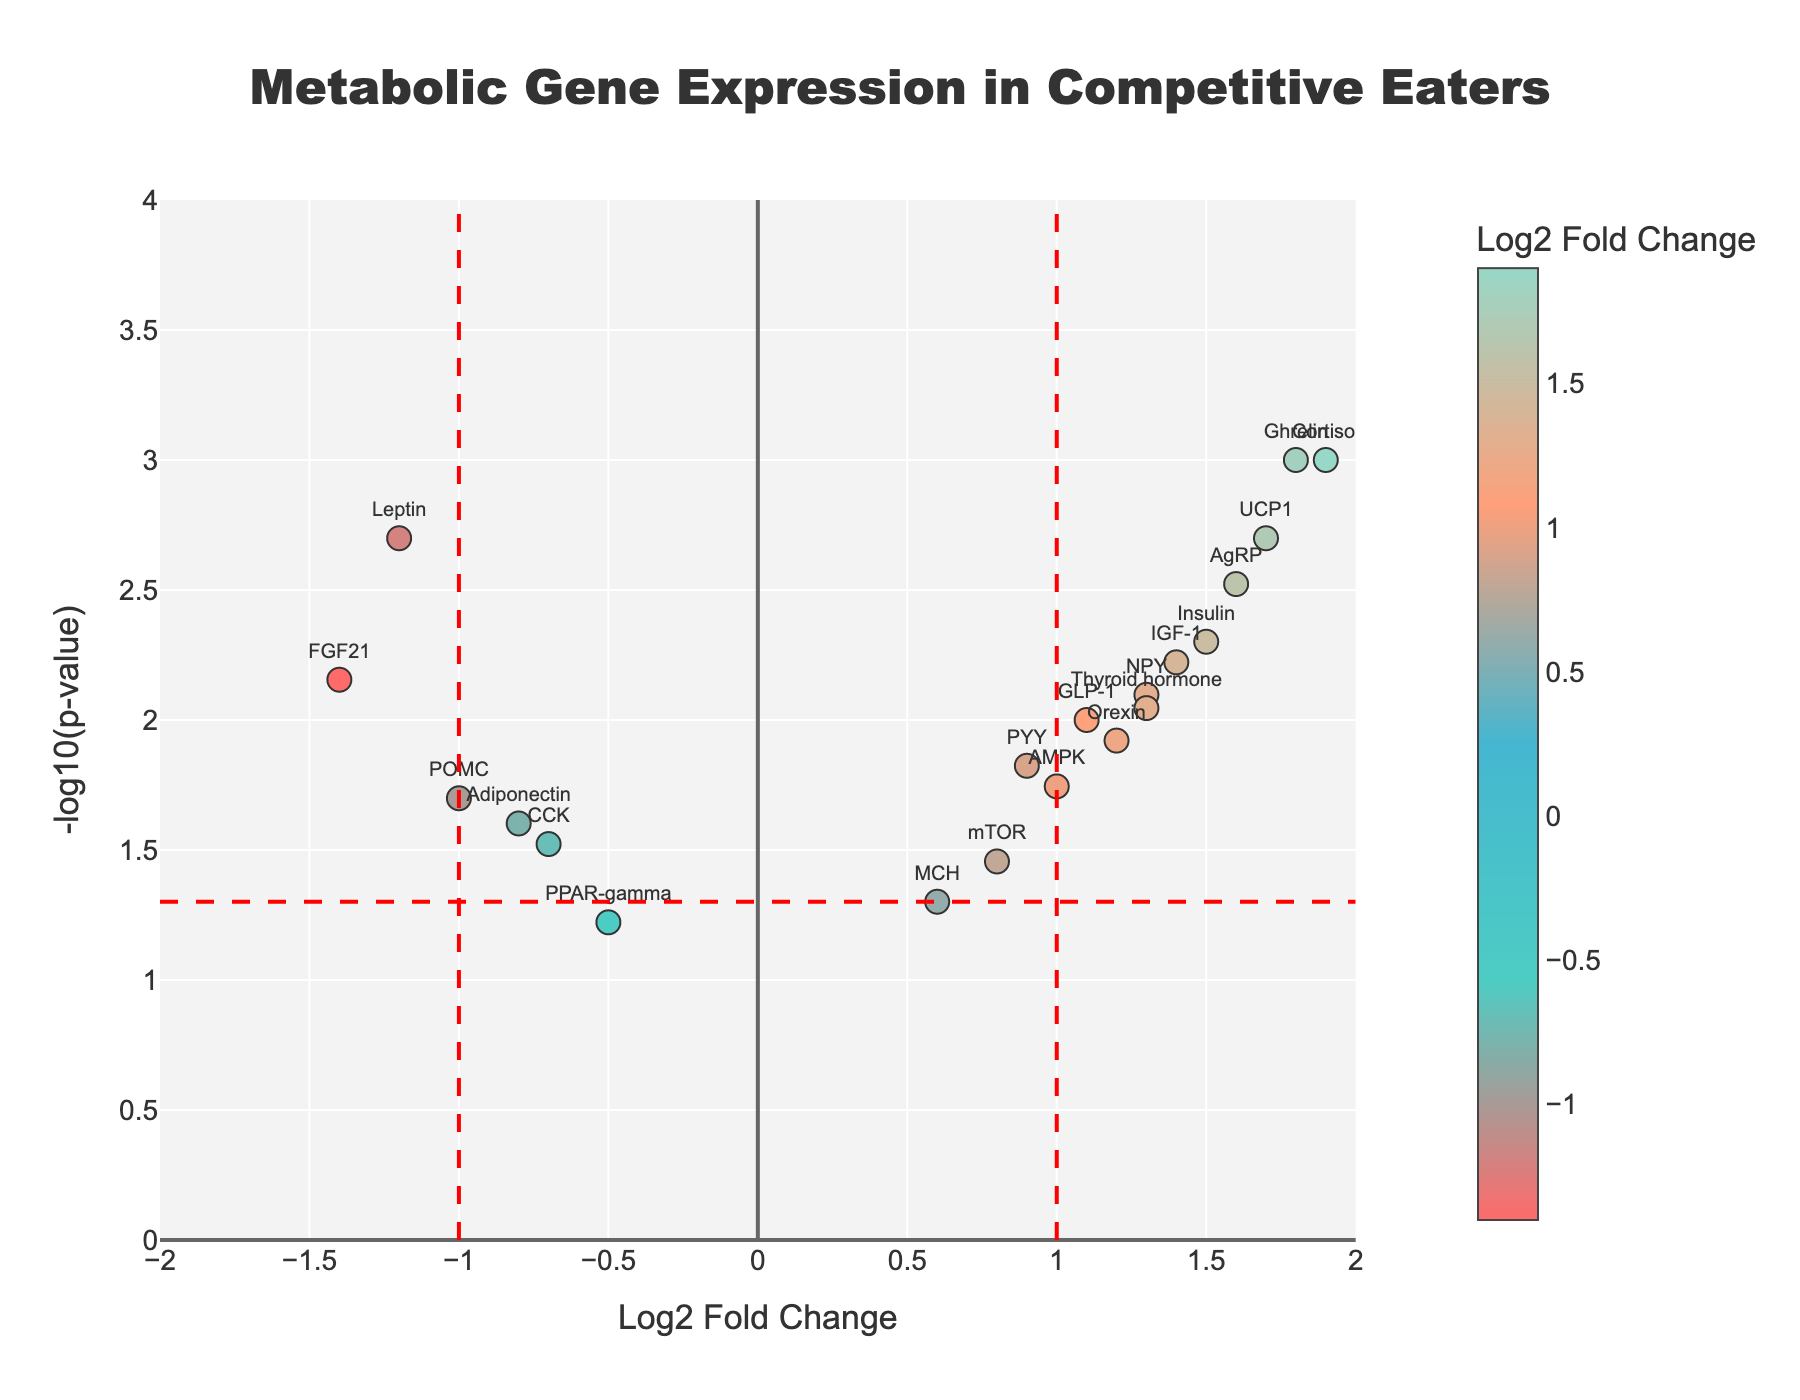What is the title of the plot? The title of the plot is located at the top center, typically written in larger font size compared to other text elements. Reading it directly from the plot would give you the title.
Answer: Metabolic Gene Expression in Competitive Eaters What is the y-axis title of the plot? The y-axis title is usually written along the y-axis, typically at a 90-degree angle to the axis. Looking at this area would show you the title.
Answer: -log10(p-value) How many genes have a Log2 Fold Change greater than 1? By examining the scatter plot, you count the number of markers to the right of the vertical line at Log2 Fold Change = 1. There are several markers representing different genes.
Answer: 9 Which gene has the highest -log10(p-value)? You need to locate the marker that is plotted at the highest position on the y-axis. The text label adjacent to this marker would indicate the gene.
Answer: Cortisol How many genes have a Log2 Fold Change less than -1? By viewing the scatter plot, count the number of markers to the left of the vertical line at Log2 Fold Change = -1. Each marker represents a gene.
Answer: 2 What does a -log10(p-value) of approximately 1.3 signify in terms of p-value? A -log10(p-value) of 1.3 translates mathematically to p-value = 10^(-1.3). Calculating this gives us an idea of the p-value.
Answer: ~0.05 Which gene has the highest positive Log2 Fold Change? By looking at the scatter plot, locate the marker farthest to the right on the x-axis. The text label near this marker shows the gene name.
Answer: Cortisol Identify a gene with a significant negative Log2 Fold Change and a small p-value. To find a gene, look for a marker to the left of Log2 Fold Change = -1 and above the -log10(p-value) = 1.3 line.
Answer: FGF21 What defines the boundary for statistical significance in the plot? The horizontal red line which meets the y-axis at -log10(p-value) = 1.3 represents the boundary for p-value = 0.05. A point above this line is statistically significant.
Answer: -log10(p-value) = 1.3 